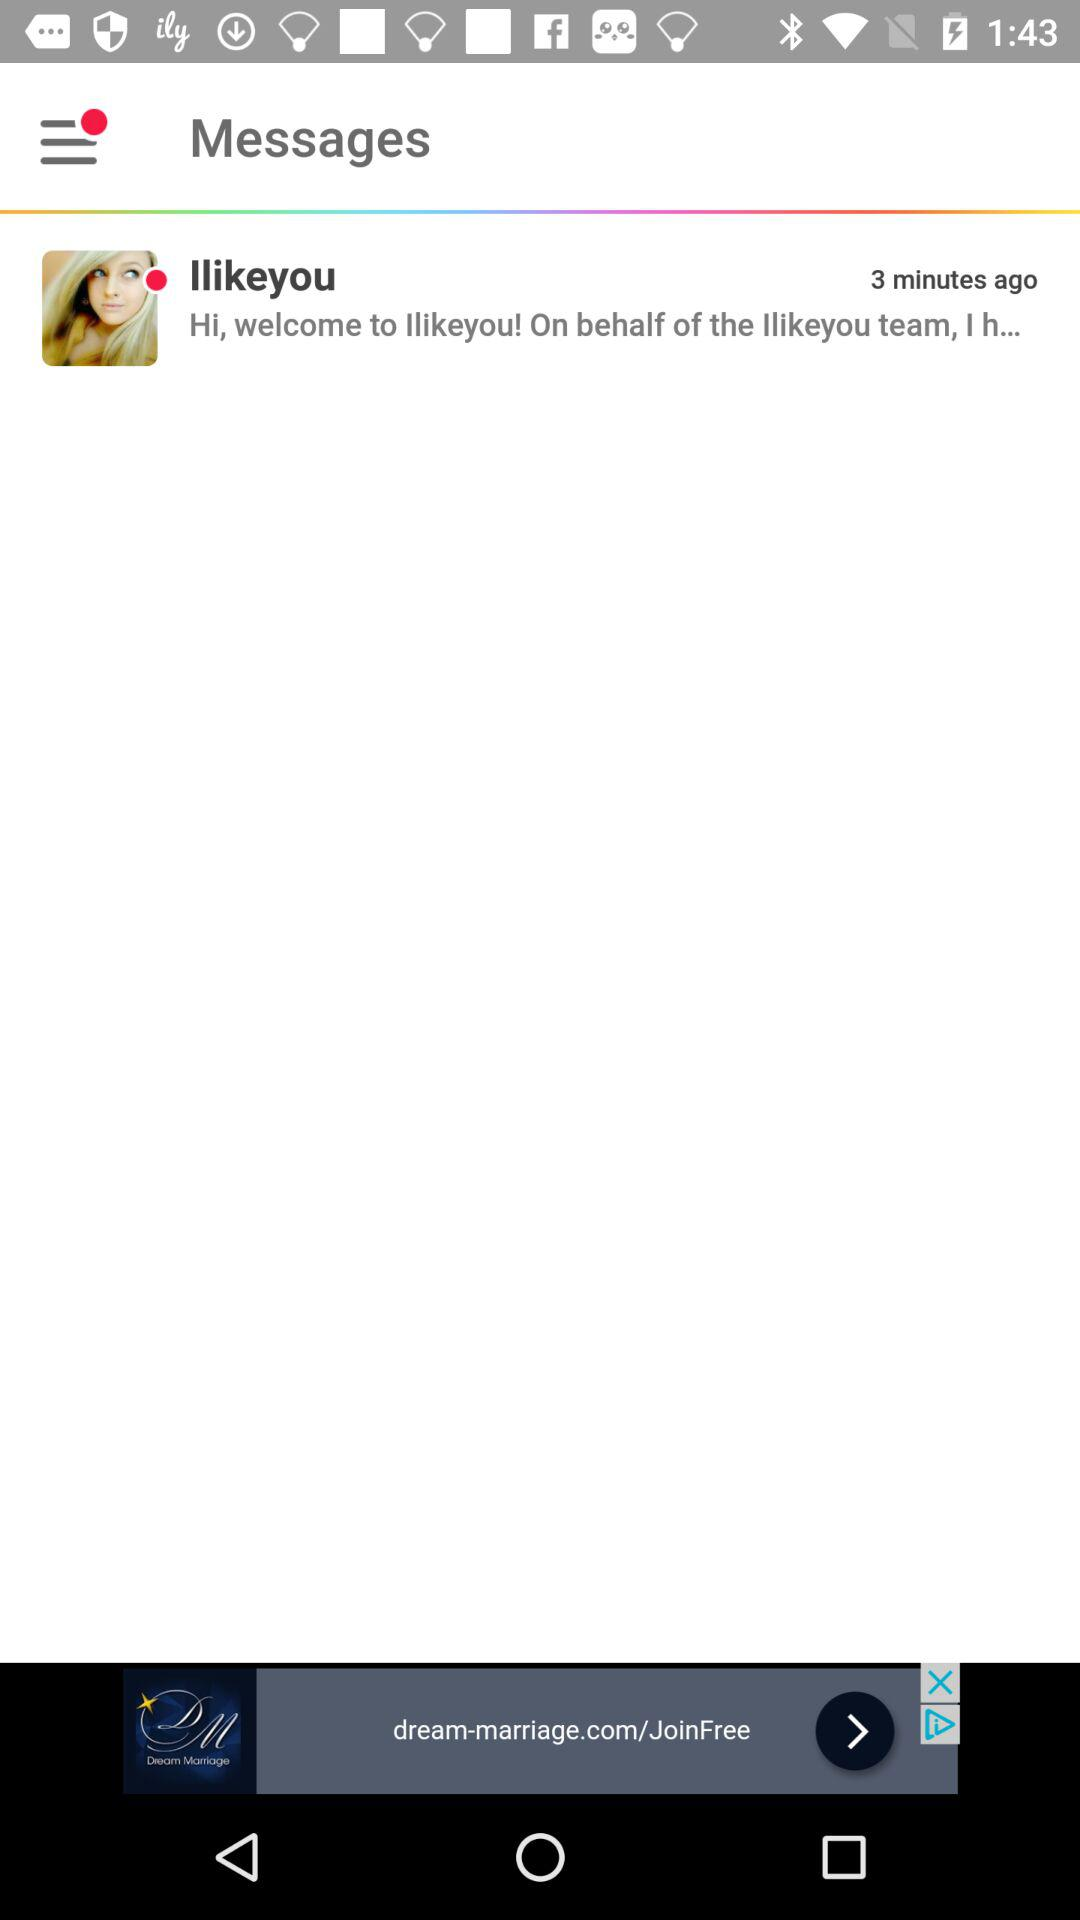What is the written message? The written message is "Hi, welcome to Ilikeyou! On behalf of the Ilikeyou team, I h...". 